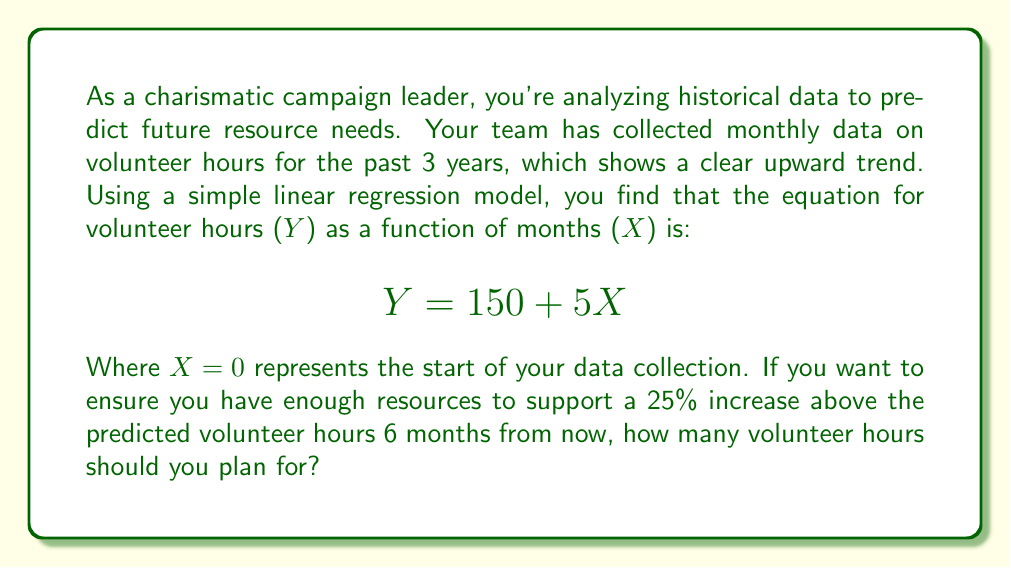Can you answer this question? To solve this problem, we'll follow these steps:

1. Determine the value of X for 6 months from now:
   Current X = 36 (3 years * 12 months)
   X in 6 months = 36 + 6 = 42

2. Calculate the predicted volunteer hours for X = 42:
   $$ Y = 150 + 5X $$
   $$ Y = 150 + 5(42) $$
   $$ Y = 150 + 210 $$
   $$ Y = 360 $$

3. Calculate a 25% increase above the predicted value:
   $$ \text{Increase} = 360 * 0.25 = 90 $$

4. Add the increase to the predicted value:
   $$ \text{Total hours} = 360 + 90 = 450 $$

As a charismatic leader, you want to ensure you have enough resources to support your growing campaign. Planning for 450 volunteer hours will accommodate the predicted growth and provide a buffer for increased engagement.
Answer: 450 volunteer hours 